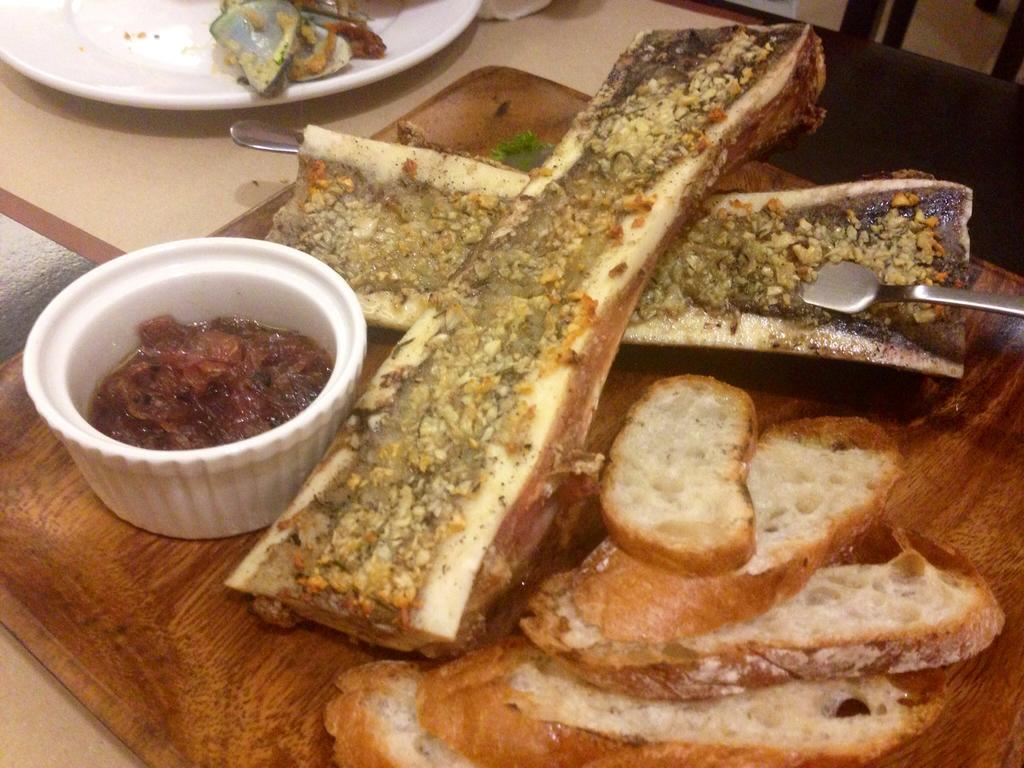What is placed on the plate in the image? There are eatable items placed on a plate in the image. Where is the plate located? The plate is placed on a table. Are there any other plates visible in the image? Yes, there are additional plates visible in the image. What type of veil can be seen draped over the chairs in the image? There are no chairs or veils present in the image; it only features a plate with eatable items and additional plates on a table. 